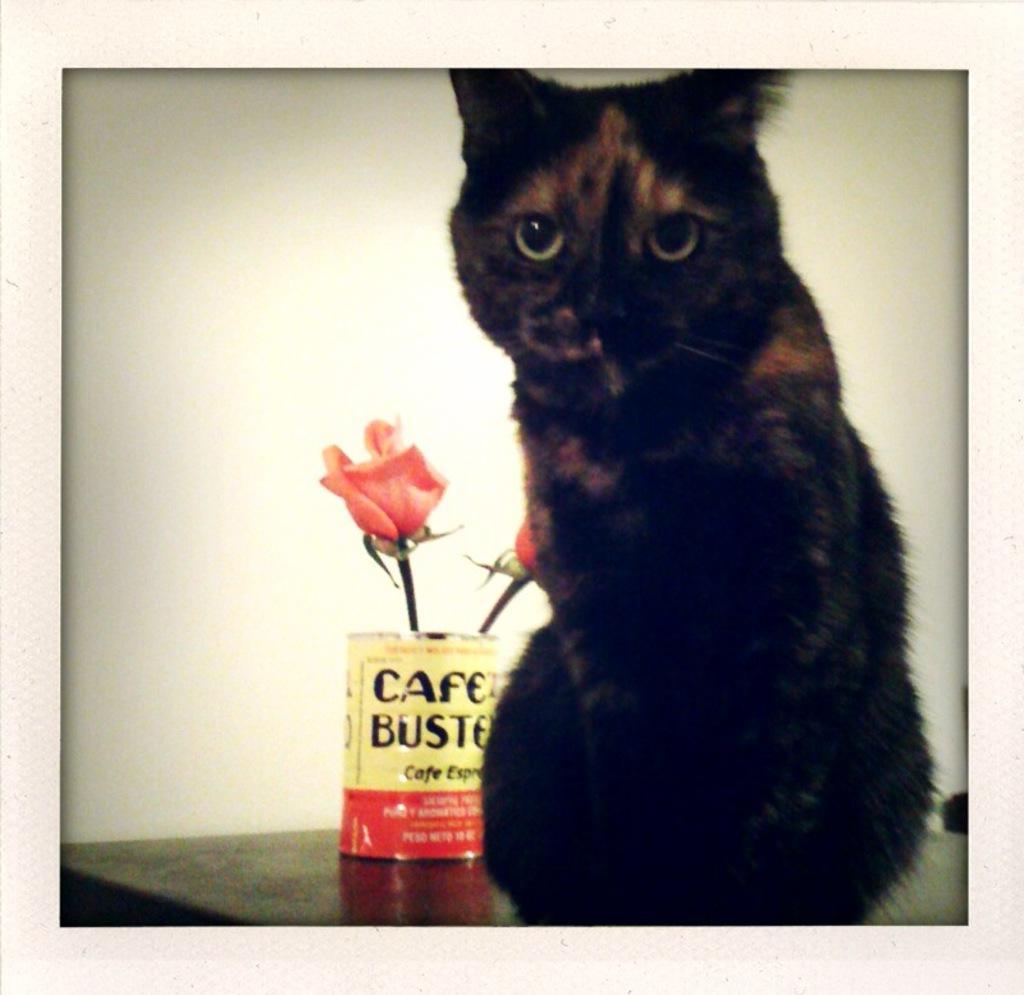Can you describe this image briefly? In this image we can see a cat on a table. We can also see some flowers in a container which is placed beside it. 